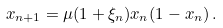Convert formula to latex. <formula><loc_0><loc_0><loc_500><loc_500>x _ { n + 1 } = \mu ( 1 + \xi _ { n } ) x _ { n } ( 1 - x _ { n } ) \, .</formula> 